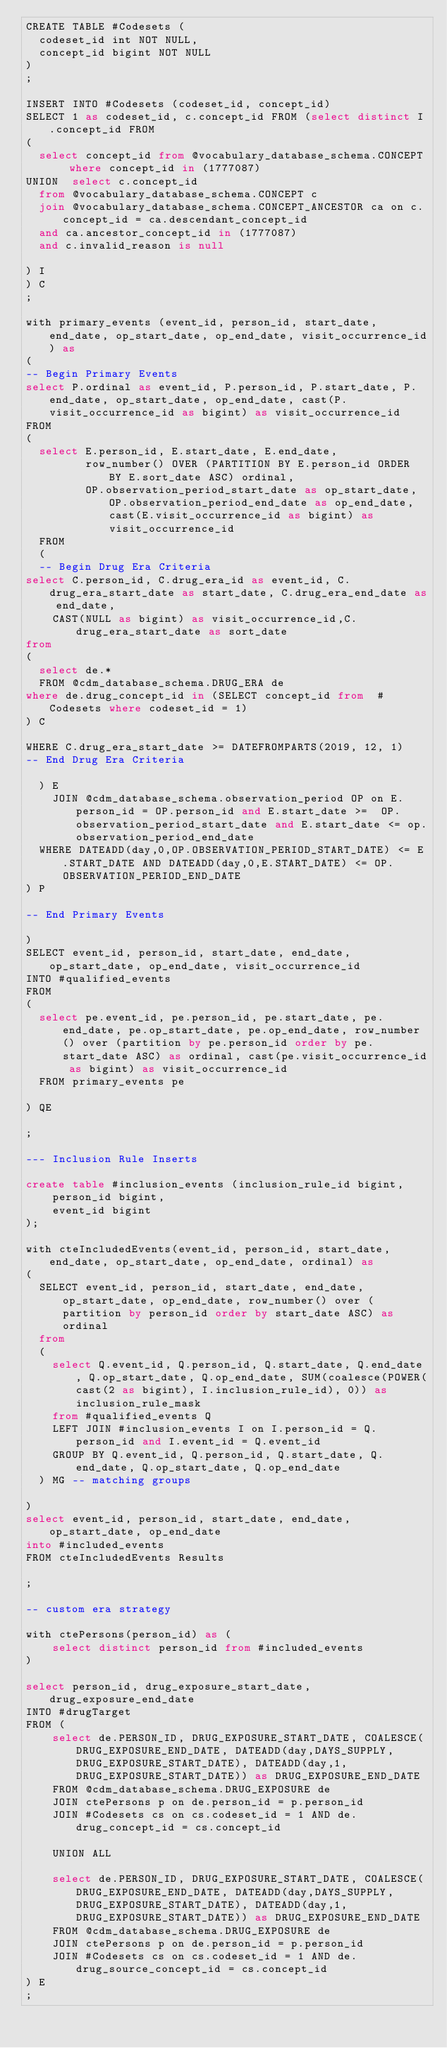Convert code to text. <code><loc_0><loc_0><loc_500><loc_500><_SQL_>CREATE TABLE #Codesets (
  codeset_id int NOT NULL,
  concept_id bigint NOT NULL
)
;

INSERT INTO #Codesets (codeset_id, concept_id)
SELECT 1 as codeset_id, c.concept_id FROM (select distinct I.concept_id FROM
( 
  select concept_id from @vocabulary_database_schema.CONCEPT where concept_id in (1777087)
UNION  select c.concept_id
  from @vocabulary_database_schema.CONCEPT c
  join @vocabulary_database_schema.CONCEPT_ANCESTOR ca on c.concept_id = ca.descendant_concept_id
  and ca.ancestor_concept_id in (1777087)
  and c.invalid_reason is null

) I
) C
;

with primary_events (event_id, person_id, start_date, end_date, op_start_date, op_end_date, visit_occurrence_id) as
(
-- Begin Primary Events
select P.ordinal as event_id, P.person_id, P.start_date, P.end_date, op_start_date, op_end_date, cast(P.visit_occurrence_id as bigint) as visit_occurrence_id
FROM
(
  select E.person_id, E.start_date, E.end_date,
         row_number() OVER (PARTITION BY E.person_id ORDER BY E.sort_date ASC) ordinal,
         OP.observation_period_start_date as op_start_date, OP.observation_period_end_date as op_end_date, cast(E.visit_occurrence_id as bigint) as visit_occurrence_id
  FROM 
  (
  -- Begin Drug Era Criteria
select C.person_id, C.drug_era_id as event_id, C.drug_era_start_date as start_date, C.drug_era_end_date as end_date,
    CAST(NULL as bigint) as visit_occurrence_id,C.drug_era_start_date as sort_date
from 
(
  select de.* 
  FROM @cdm_database_schema.DRUG_ERA de
where de.drug_concept_id in (SELECT concept_id from  #Codesets where codeset_id = 1)
) C

WHERE C.drug_era_start_date >= DATEFROMPARTS(2019, 12, 1)
-- End Drug Era Criteria

  ) E
	JOIN @cdm_database_schema.observation_period OP on E.person_id = OP.person_id and E.start_date >=  OP.observation_period_start_date and E.start_date <= op.observation_period_end_date
  WHERE DATEADD(day,0,OP.OBSERVATION_PERIOD_START_DATE) <= E.START_DATE AND DATEADD(day,0,E.START_DATE) <= OP.OBSERVATION_PERIOD_END_DATE
) P

-- End Primary Events

)
SELECT event_id, person_id, start_date, end_date, op_start_date, op_end_date, visit_occurrence_id
INTO #qualified_events
FROM 
(
  select pe.event_id, pe.person_id, pe.start_date, pe.end_date, pe.op_start_date, pe.op_end_date, row_number() over (partition by pe.person_id order by pe.start_date ASC) as ordinal, cast(pe.visit_occurrence_id as bigint) as visit_occurrence_id
  FROM primary_events pe
  
) QE

;

--- Inclusion Rule Inserts

create table #inclusion_events (inclusion_rule_id bigint,
	person_id bigint,
	event_id bigint
);

with cteIncludedEvents(event_id, person_id, start_date, end_date, op_start_date, op_end_date, ordinal) as
(
  SELECT event_id, person_id, start_date, end_date, op_start_date, op_end_date, row_number() over (partition by person_id order by start_date ASC) as ordinal
  from
  (
    select Q.event_id, Q.person_id, Q.start_date, Q.end_date, Q.op_start_date, Q.op_end_date, SUM(coalesce(POWER(cast(2 as bigint), I.inclusion_rule_id), 0)) as inclusion_rule_mask
    from #qualified_events Q
    LEFT JOIN #inclusion_events I on I.person_id = Q.person_id and I.event_id = Q.event_id
    GROUP BY Q.event_id, Q.person_id, Q.start_date, Q.end_date, Q.op_start_date, Q.op_end_date
  ) MG -- matching groups

)
select event_id, person_id, start_date, end_date, op_start_date, op_end_date
into #included_events
FROM cteIncludedEvents Results

;

-- custom era strategy

with ctePersons(person_id) as (
	select distinct person_id from #included_events
)

select person_id, drug_exposure_start_date, drug_exposure_end_date
INTO #drugTarget
FROM (
	select de.PERSON_ID, DRUG_EXPOSURE_START_DATE, COALESCE(DRUG_EXPOSURE_END_DATE, DATEADD(day,DAYS_SUPPLY,DRUG_EXPOSURE_START_DATE), DATEADD(day,1,DRUG_EXPOSURE_START_DATE)) as DRUG_EXPOSURE_END_DATE 
	FROM @cdm_database_schema.DRUG_EXPOSURE de
	JOIN ctePersons p on de.person_id = p.person_id
	JOIN #Codesets cs on cs.codeset_id = 1 AND de.drug_concept_id = cs.concept_id

	UNION ALL

	select de.PERSON_ID, DRUG_EXPOSURE_START_DATE, COALESCE(DRUG_EXPOSURE_END_DATE, DATEADD(day,DAYS_SUPPLY,DRUG_EXPOSURE_START_DATE), DATEADD(day,1,DRUG_EXPOSURE_START_DATE)) as DRUG_EXPOSURE_END_DATE 
	FROM @cdm_database_schema.DRUG_EXPOSURE de
	JOIN ctePersons p on de.person_id = p.person_id
	JOIN #Codesets cs on cs.codeset_id = 1 AND de.drug_source_concept_id = cs.concept_id
) E
;
</code> 